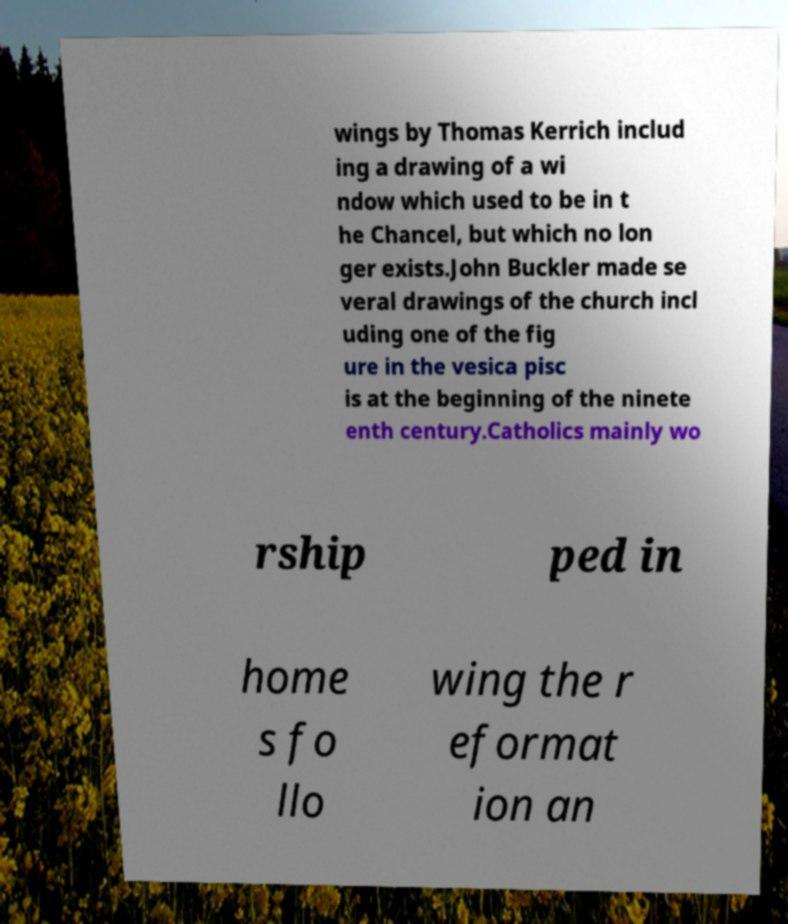Could you extract and type out the text from this image? wings by Thomas Kerrich includ ing a drawing of a wi ndow which used to be in t he Chancel, but which no lon ger exists.John Buckler made se veral drawings of the church incl uding one of the fig ure in the vesica pisc is at the beginning of the ninete enth century.Catholics mainly wo rship ped in home s fo llo wing the r eformat ion an 